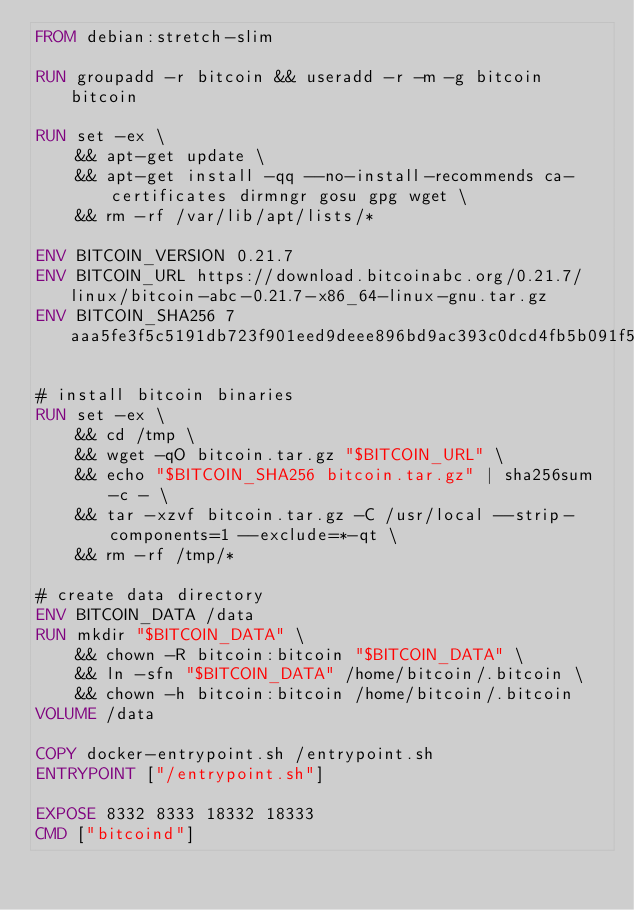<code> <loc_0><loc_0><loc_500><loc_500><_Dockerfile_>FROM debian:stretch-slim

RUN groupadd -r bitcoin && useradd -r -m -g bitcoin bitcoin

RUN set -ex \
	&& apt-get update \
	&& apt-get install -qq --no-install-recommends ca-certificates dirmngr gosu gpg wget \
	&& rm -rf /var/lib/apt/lists/*

ENV BITCOIN_VERSION 0.21.7
ENV BITCOIN_URL https://download.bitcoinabc.org/0.21.7/linux/bitcoin-abc-0.21.7-x86_64-linux-gnu.tar.gz
ENV BITCOIN_SHA256 7aaa5fe3f5c5191db723f901eed9deee896bd9ac393c0dcd4fb5b091f57e74e8

# install bitcoin binaries
RUN set -ex \
	&& cd /tmp \
	&& wget -qO bitcoin.tar.gz "$BITCOIN_URL" \
	&& echo "$BITCOIN_SHA256 bitcoin.tar.gz" | sha256sum -c - \
	&& tar -xzvf bitcoin.tar.gz -C /usr/local --strip-components=1 --exclude=*-qt \
	&& rm -rf /tmp/*

# create data directory
ENV BITCOIN_DATA /data
RUN mkdir "$BITCOIN_DATA" \
	&& chown -R bitcoin:bitcoin "$BITCOIN_DATA" \
	&& ln -sfn "$BITCOIN_DATA" /home/bitcoin/.bitcoin \
	&& chown -h bitcoin:bitcoin /home/bitcoin/.bitcoin
VOLUME /data

COPY docker-entrypoint.sh /entrypoint.sh
ENTRYPOINT ["/entrypoint.sh"]

EXPOSE 8332 8333 18332 18333
CMD ["bitcoind"]
</code> 